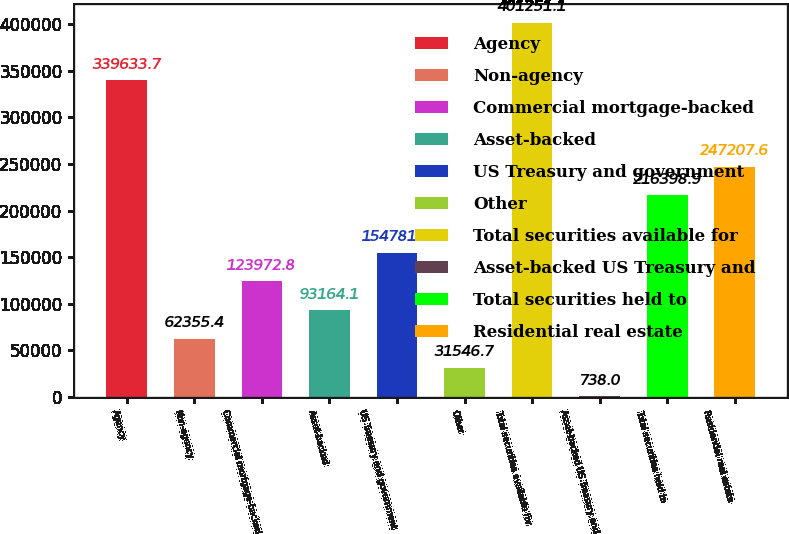Convert chart to OTSL. <chart><loc_0><loc_0><loc_500><loc_500><bar_chart><fcel>Agency<fcel>Non-agency<fcel>Commercial mortgage-backed<fcel>Asset-backed<fcel>US Treasury and government<fcel>Other<fcel>Total securities available for<fcel>Asset-backed US Treasury and<fcel>Total securities held to<fcel>Residential real estate<nl><fcel>339634<fcel>62355.4<fcel>123973<fcel>93164.1<fcel>154782<fcel>31546.7<fcel>401251<fcel>738<fcel>216399<fcel>247208<nl></chart> 